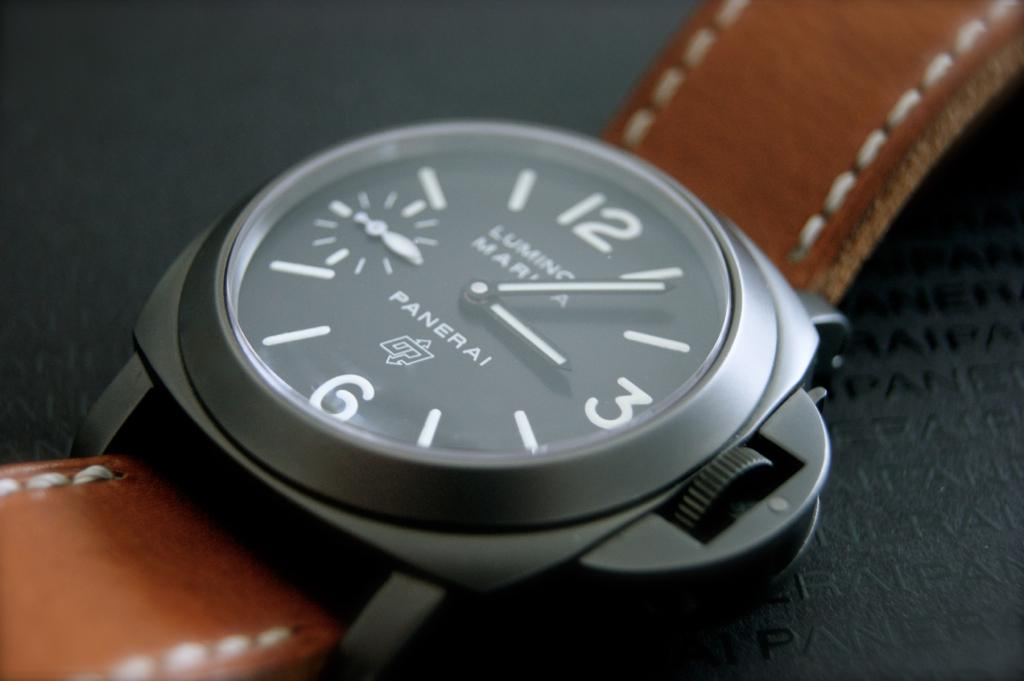How would you describe the aesthetics of this watch? The watch exudes a blend of modern and vintage aesthetics, with a clean, easy-to-read dial that hints at a utilitarian design. The dark palette of the watch face paired with the warmth of the leather strap creates an elegant contrast that appeals to connoisseurs of timeless style. 